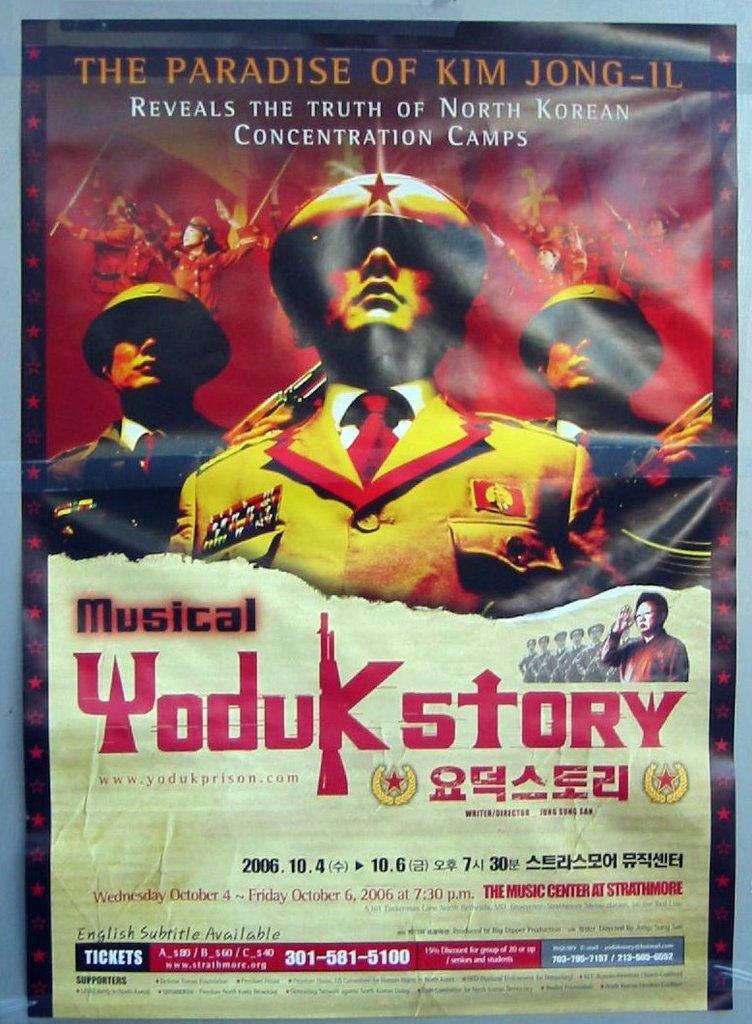What is the tagline about kim jong-il?
Provide a succinct answer. Reveals the truth of north korean concentration camps. What does this reveal the truth of?
Provide a succinct answer. North korean concentration camps. 